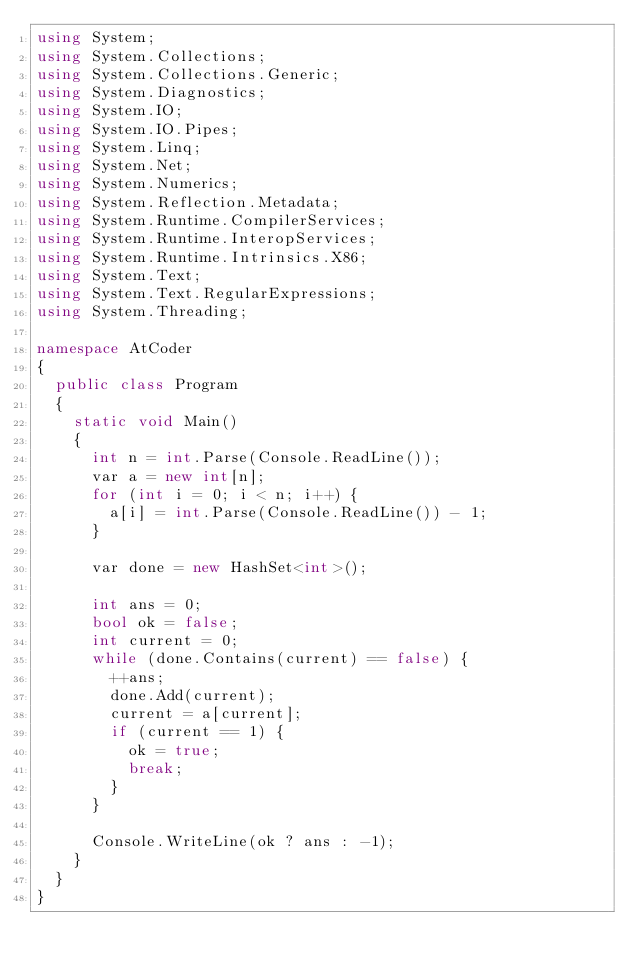<code> <loc_0><loc_0><loc_500><loc_500><_C#_>using System;
using System.Collections;
using System.Collections.Generic;
using System.Diagnostics;
using System.IO;
using System.IO.Pipes;
using System.Linq;
using System.Net;
using System.Numerics;
using System.Reflection.Metadata;
using System.Runtime.CompilerServices;
using System.Runtime.InteropServices;
using System.Runtime.Intrinsics.X86;
using System.Text;
using System.Text.RegularExpressions;
using System.Threading;

namespace AtCoder
{
	public class Program
	{
		static void Main()
		{
			int n = int.Parse(Console.ReadLine());
			var a = new int[n];
			for (int i = 0; i < n; i++) {
				a[i] = int.Parse(Console.ReadLine()) - 1;
			}

			var done = new HashSet<int>();
			
			int ans = 0;
			bool ok = false;
			int current = 0;
			while (done.Contains(current) == false) {
				++ans;
				done.Add(current);
				current = a[current];
				if (current == 1) {
					ok = true;
					break;
				}
			}

			Console.WriteLine(ok ? ans : -1);
		}
	}
}
</code> 